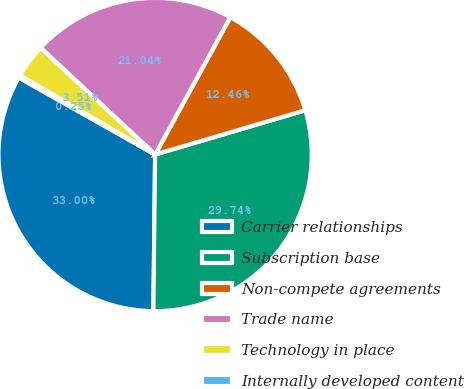Convert chart. <chart><loc_0><loc_0><loc_500><loc_500><pie_chart><fcel>Carrier relationships<fcel>Subscription base<fcel>Non-compete agreements<fcel>Trade name<fcel>Technology in place<fcel>Internally developed content<nl><fcel>33.0%<fcel>29.74%<fcel>12.46%<fcel>21.04%<fcel>3.51%<fcel>0.25%<nl></chart> 